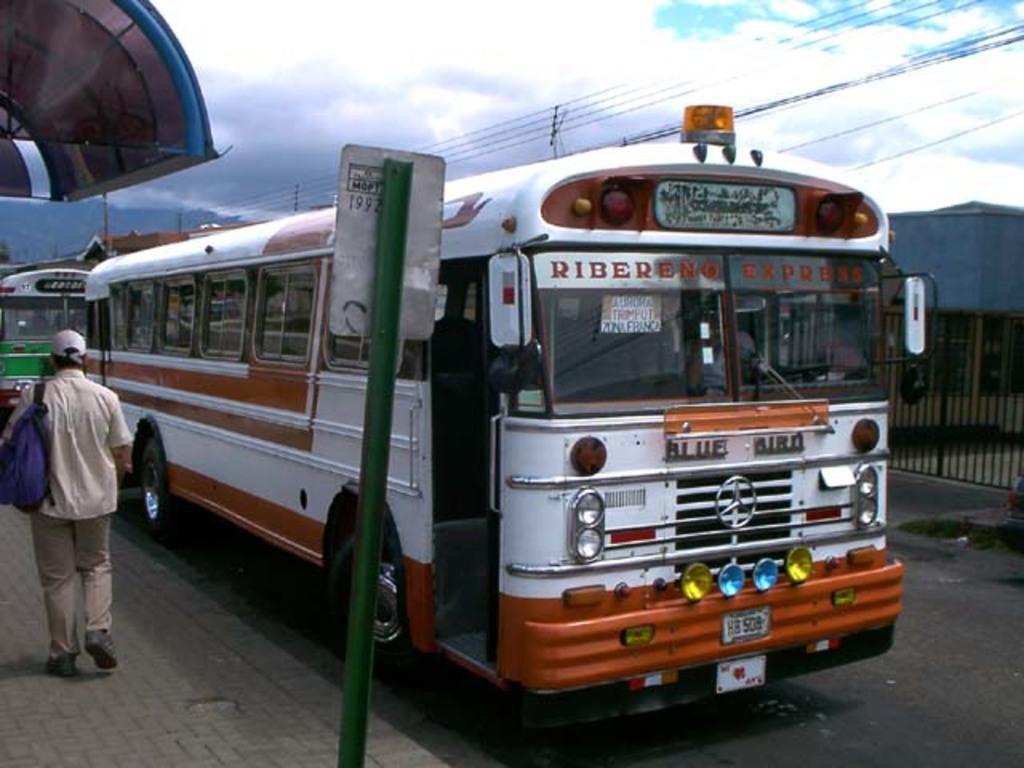Please provide a concise description of this image. A person is walking at the left. There is a sign board, buses on the road. At the right there is fencing, buildings and wires on the top. 